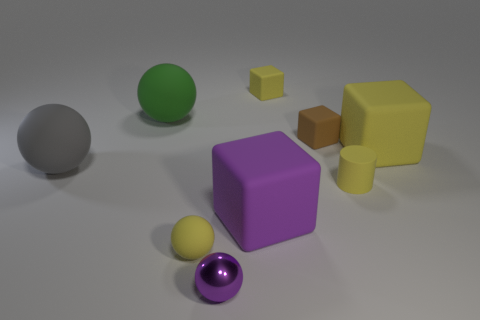Subtract all spheres. How many objects are left? 5 Add 5 blocks. How many blocks exist? 9 Subtract 1 yellow cylinders. How many objects are left? 8 Subtract all small purple metal balls. Subtract all brown objects. How many objects are left? 7 Add 5 big matte cubes. How many big matte cubes are left? 7 